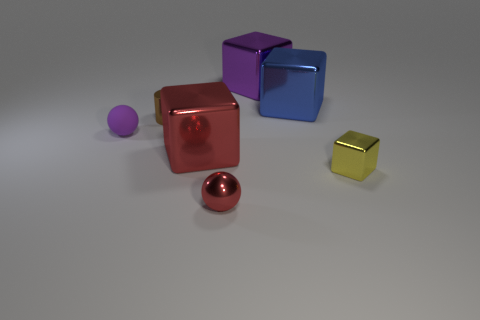The cylinder is what color? The image does not contain a cylinder; thus, a color cannot be provided for it. However, there are various colorful objects in the image, including a sphere that is crimson red, a small cube that is yellow, larger cubes in red, blue, and purple, as well as a small purple spherical object. 